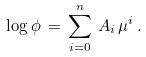<formula> <loc_0><loc_0><loc_500><loc_500>\log \phi \, = \, \sum _ { i = 0 } ^ { n } \, A _ { i } \, \mu ^ { i } \, .</formula> 